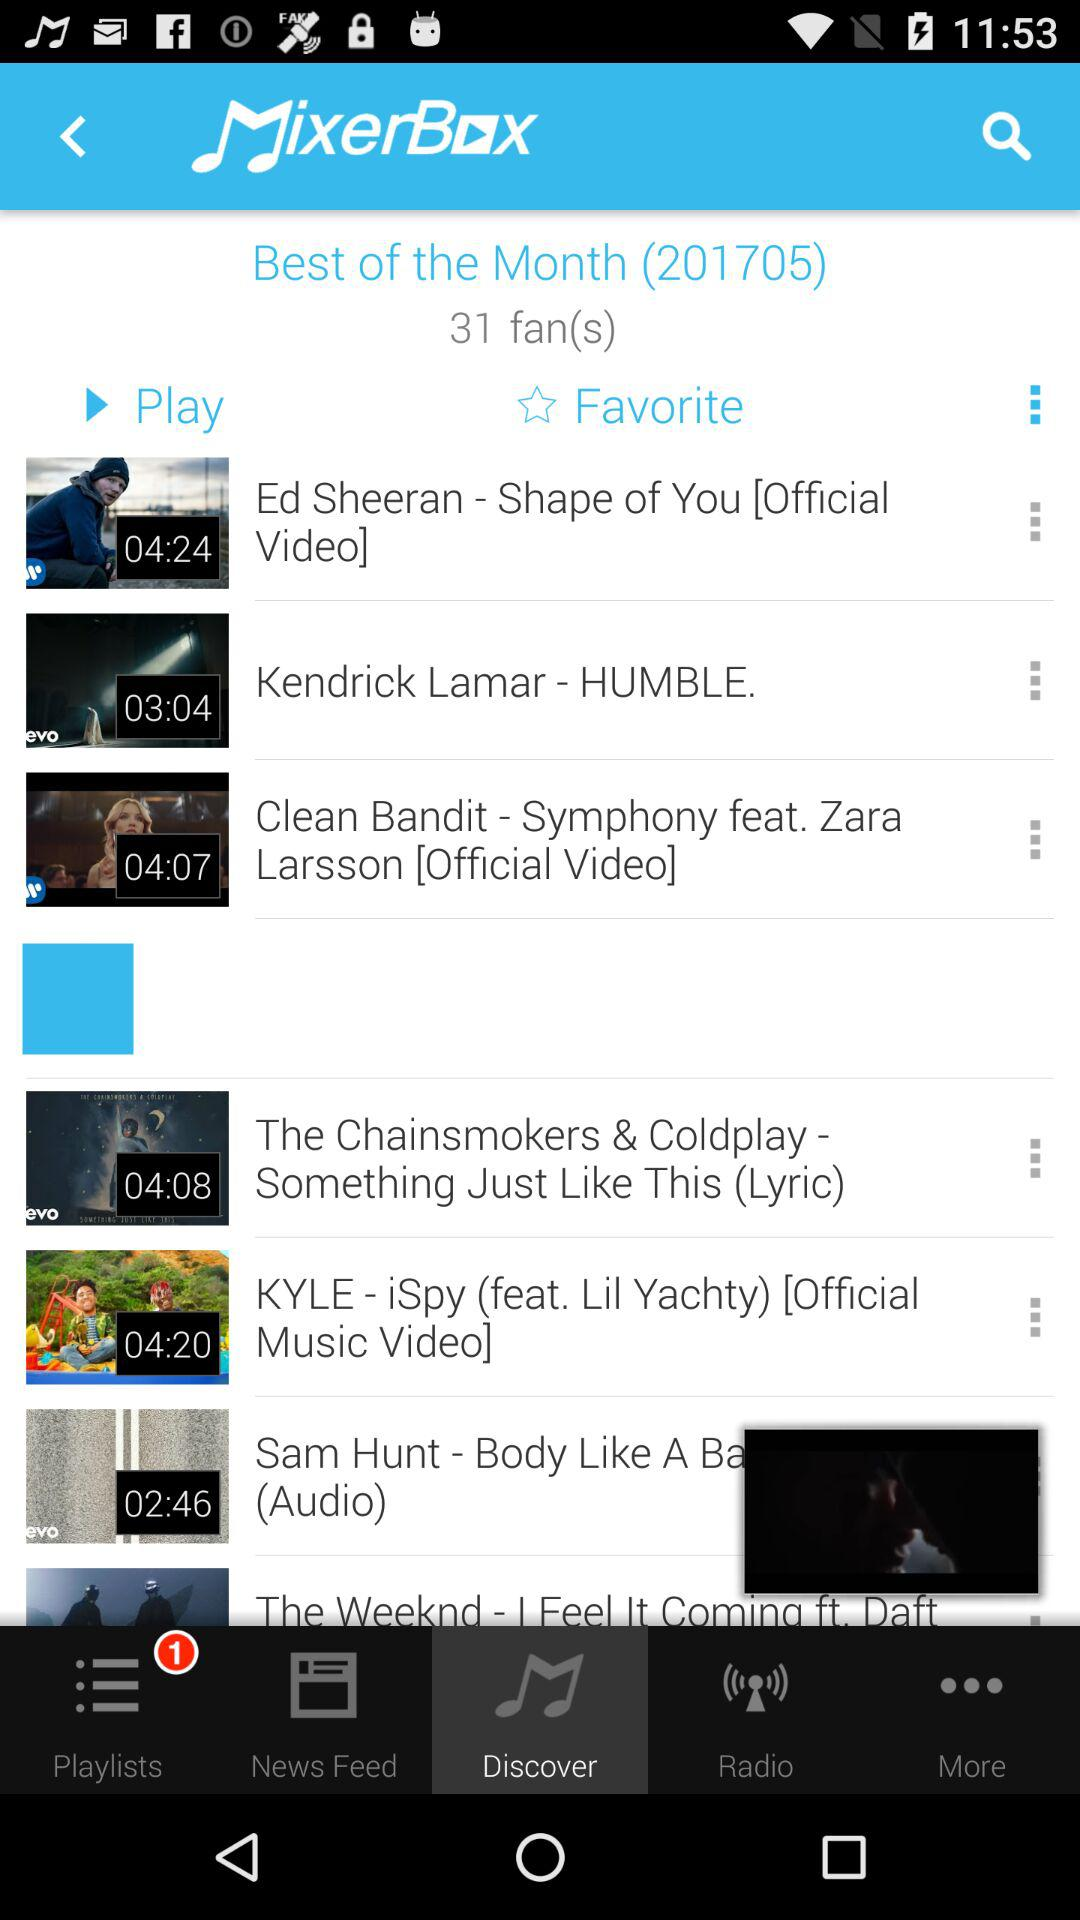How many songs are there in the playlist?
When the provided information is insufficient, respond with <no answer>. <no answer> 